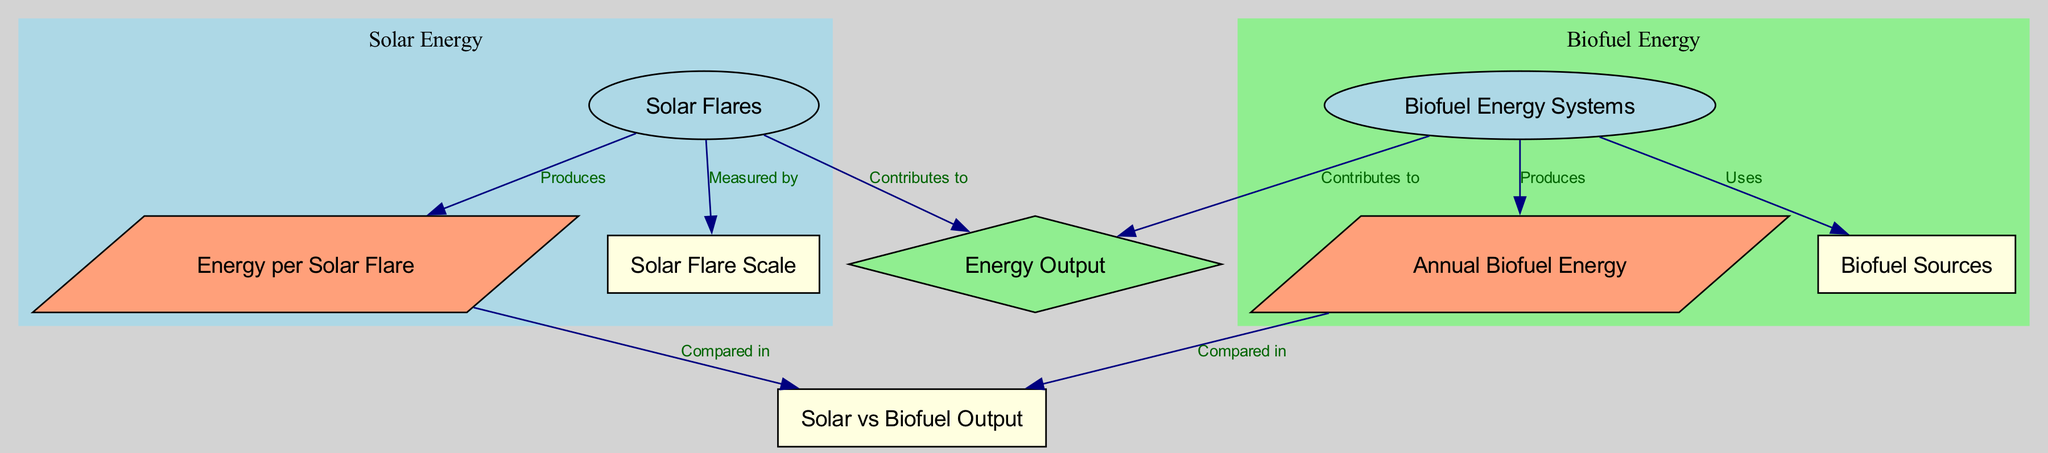What contributes to energy output? The diagram shows that both solar flares and biofuel energy systems contribute to energy output as indicated by their edges pointing to the "Energy Output" node.
Answer: Solar flares, Biofuel Energy Systems What is measured by solar event scale? The solar event scale is indicated to be related to solar flares in the diagram, which directly connects to it.
Answer: Solar Flares How many nodes are in the diagram? The diagram consists of a total of eight nodes as listed, which can be counted visually.
Answer: Eight What produces energy per solar flare? The diagram specifies that solar flares produce "Energy per Solar Flare," linking the two nodes through an edge.
Answer: Energy per Solar Flare Which biofuel energy system produces annual biofuel energy? The edge in the diagram shows that the biofuel systems produce "Annual Biofuel Energy," directly establishing this relationship.
Answer: Biofuel Energy Systems What is compared in solar vs biofuel output? The diagram indicates that both "Energy per Solar Flare" and "Annual Biofuel Energy" are compared in the node labeled "Solar vs Biofuel Output."
Answer: Energy per Solar Flare, Annual Biofuel Energy Which biofuel sources are utilized? The diagram connects "Biofuel Energy Systems" to "Biofuel Sources," indicating that the energy systems utilize these sources.
Answer: Biofuel Sources How does solar energy compare to biofuel energy systems? The comparison emerges from two nodes "Energy per Solar Flare" and "Annual Biofuel Energy," meaning the outputs from both energy types are juxtaposed in the final comparison node.
Answer: Compared in Solar vs Biofuel Output 